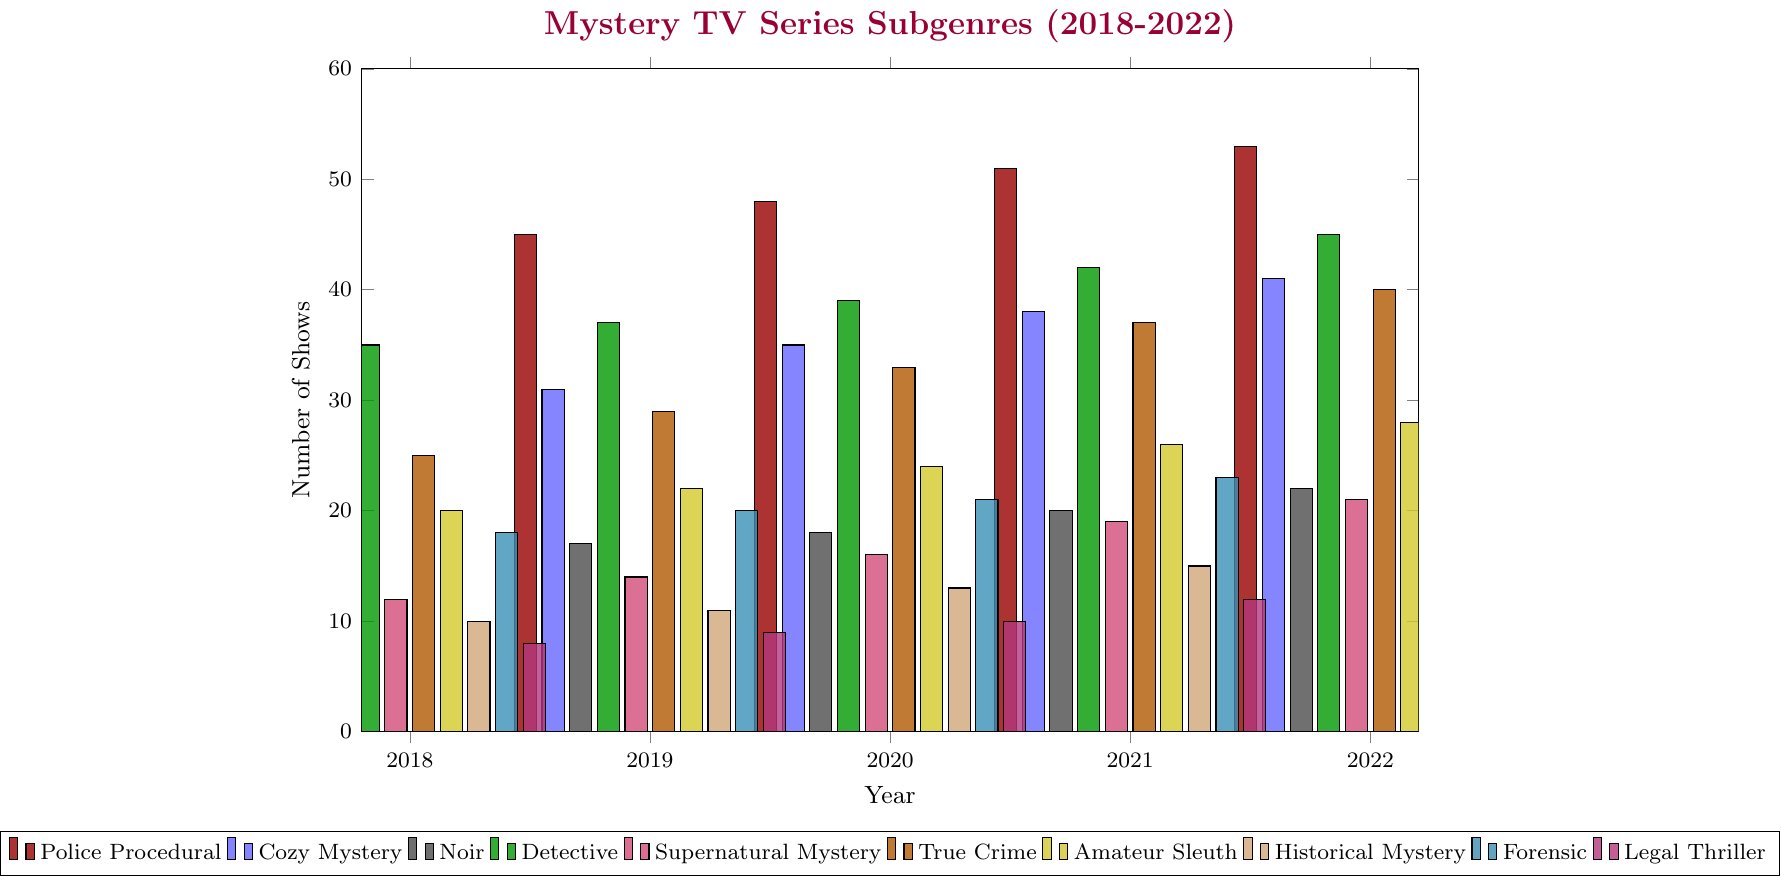What is the trend in the number of Police Procedural shows from 2018 to 2022? Look at the height of the red bars for the Police Procedural subgenre across the years 2018 to 2022. The heights of the bars are progressively higher each year from 42 in 2018 to 53 in 2022, indicating an increasing trend.
Answer: Increasing Which subgenre had more shows produced in 2022, Cozy Mystery or Noir? Compare the heights of the blue bar (Cozy Mystery) and the black bar (Noir) for the year 2022. The blue bar is taller with 41 shows compared to the black bar with 22 shows.
Answer: Cozy Mystery What is the difference in the number of True Crime shows between 2018 and 2022? The height of the orange bar for True Crime subgenre in 2018 is 25, and in 2022 it is 40. The difference is calculated as 40 - 25.
Answer: 15 Among all subgenres, which one had the lowest number of shows produced in 2021? Look at the year 2021 and identify the shortest bar. The shortest bar in 2021 is magenta (Legal Thriller) with 12 shows.
Answer: Legal Thriller How many shows were produced in total for the subgenre Detective from 2018 to 2022? Sum the height of the green bars for Detective for each year: \(35 + 37 + 39 + 42 + 45 = 198\).
Answer: 198 In which year did the Forensic subgenre have 23 shows produced? Identify the year corresponding to the height of the cyan bar (Forensic) that is closest to 23. It is in the year 2021.
Answer: 2021 Which subgenre showed consistent incremental growth every year from 2018 to 2022? From the provided data, a consistent incremental growth every year can be verified by checking the increase year by year. Cozy Mystery's blue bars increase from 28 in 2018 to 41 in 2022 with a steady increment each year.
Answer: Cozy Mystery What is the average number of shows produced annually for Supernatural Mystery from 2018 to 2022? Calculate the average by summing the purple bar heights for Supernatural Mystery and then dividing by 5: \((12 + 14 + 16 + 19 + 21) / 5 = 82 / 5 = 16.4\).
Answer: 16.4 How does the number of Historical Mystery shows in 2020 compare to those in 2022? Compare the height of the brown bars for Historical Mystery in 2020 and 2022. In 2020, there are 13 shows, and in 2022, there are 17 shows.
Answer: There are more in 2022 Which subgenre had the second-highest number of shows produced in 2019? Identify the second tallest bar for the year 2019. The green bar (Detective) with 37 shows is the second tallest after the red bar (Police Procedural) with 45 shows.
Answer: Detective 